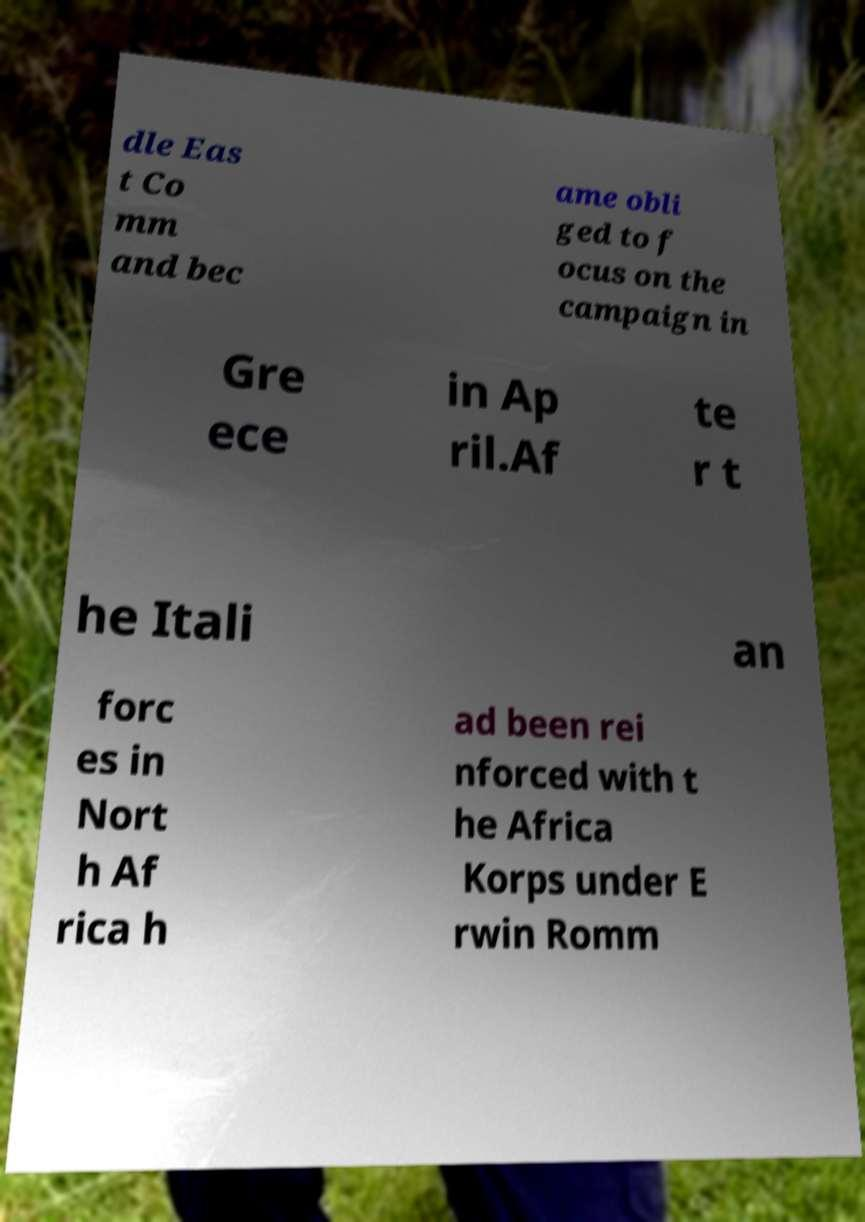Please identify and transcribe the text found in this image. dle Eas t Co mm and bec ame obli ged to f ocus on the campaign in Gre ece in Ap ril.Af te r t he Itali an forc es in Nort h Af rica h ad been rei nforced with t he Africa Korps under E rwin Romm 